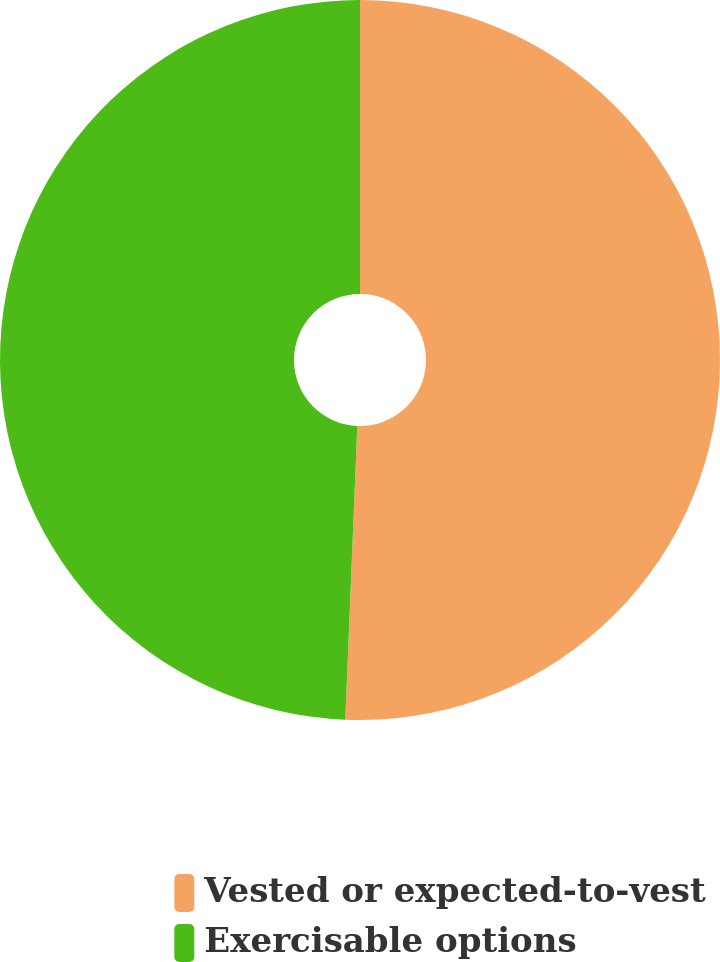<chart> <loc_0><loc_0><loc_500><loc_500><pie_chart><fcel>Vested or expected-to-vest<fcel>Exercisable options<nl><fcel>50.65%<fcel>49.35%<nl></chart> 